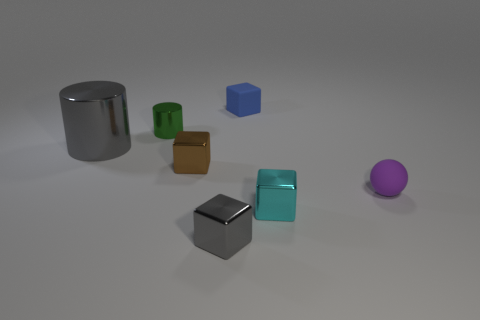Add 2 cyan things. How many objects exist? 9 Subtract all cylinders. How many objects are left? 5 Add 1 big brown metal cylinders. How many big brown metal cylinders exist? 1 Subtract 0 purple cubes. How many objects are left? 7 Subtract all tiny green objects. Subtract all gray metal blocks. How many objects are left? 5 Add 2 large gray things. How many large gray things are left? 3 